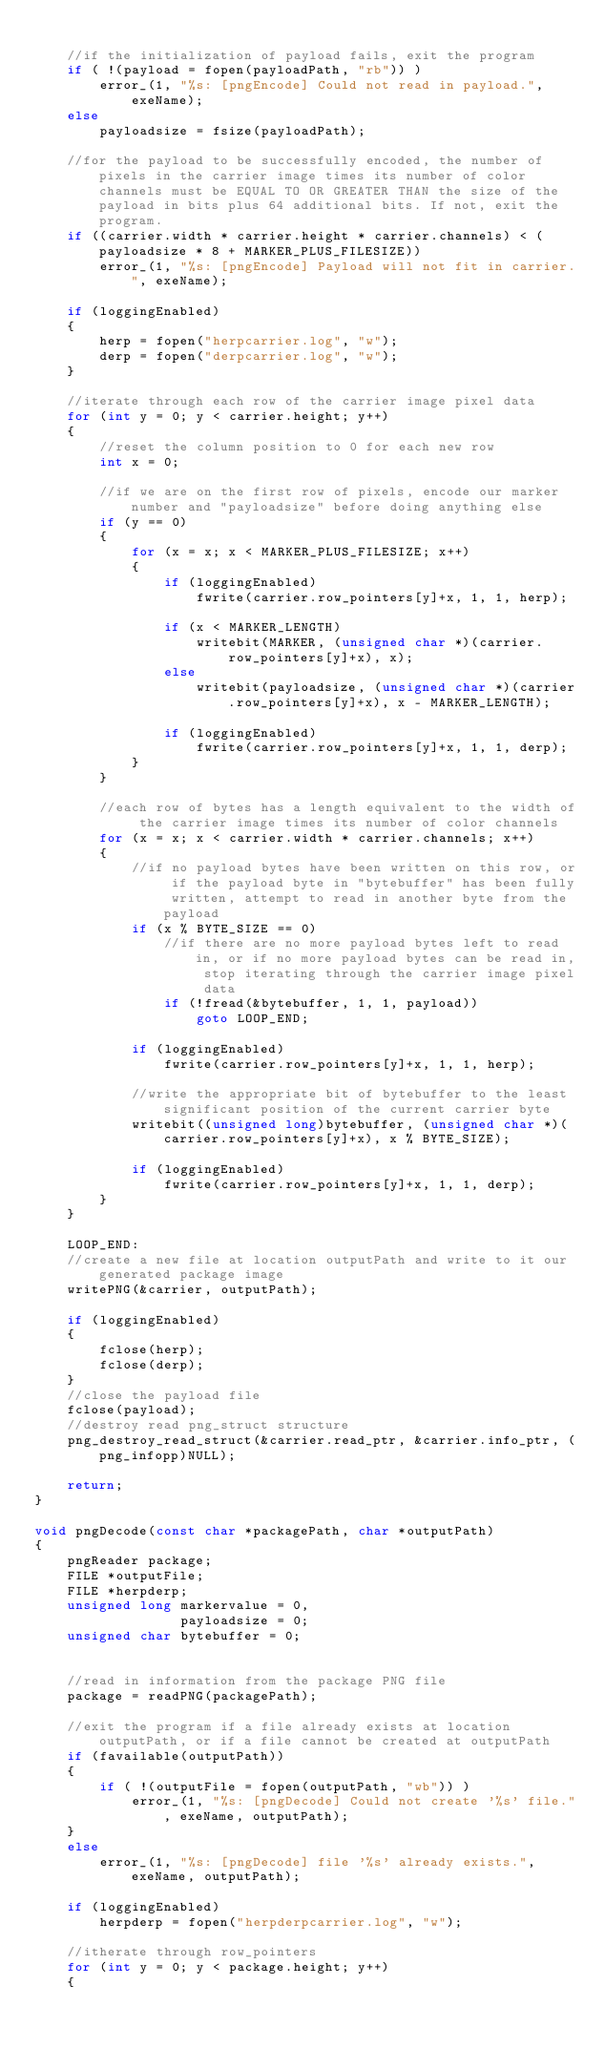Convert code to text. <code><loc_0><loc_0><loc_500><loc_500><_C_>
    //if the initialization of payload fails, exit the program
    if ( !(payload = fopen(payloadPath, "rb")) )
        error_(1, "%s: [pngEncode] Could not read in payload.", exeName);
    else
        payloadsize = fsize(payloadPath);

    //for the payload to be successfully encoded, the number of pixels in the carrier image times its number of color channels must be EQUAL TO OR GREATER THAN the size of the payload in bits plus 64 additional bits. If not, exit the program.
    if ((carrier.width * carrier.height * carrier.channels) < (payloadsize * 8 + MARKER_PLUS_FILESIZE))
        error_(1, "%s: [pngEncode] Payload will not fit in carrier.", exeName);

    if (loggingEnabled)
    {
        herp = fopen("herpcarrier.log", "w");
        derp = fopen("derpcarrier.log", "w");
    }

    //iterate through each row of the carrier image pixel data
    for (int y = 0; y < carrier.height; y++)
    {
        //reset the column position to 0 for each new row
        int x = 0;

        //if we are on the first row of pixels, encode our marker number and "payloadsize" before doing anything else
        if (y == 0)
        {
            for (x = x; x < MARKER_PLUS_FILESIZE; x++)
            {
                if (loggingEnabled)
                    fwrite(carrier.row_pointers[y]+x, 1, 1, herp);

                if (x < MARKER_LENGTH)
                    writebit(MARKER, (unsigned char *)(carrier.row_pointers[y]+x), x);
                else
                    writebit(payloadsize, (unsigned char *)(carrier.row_pointers[y]+x), x - MARKER_LENGTH);

                if (loggingEnabled)
                    fwrite(carrier.row_pointers[y]+x, 1, 1, derp);
            }
        }

        //each row of bytes has a length equivalent to the width of the carrier image times its number of color channels
        for (x = x; x < carrier.width * carrier.channels; x++)
        {
            //if no payload bytes have been written on this row, or if the payload byte in "bytebuffer" has been fully written, attempt to read in another byte from the payload
            if (x % BYTE_SIZE == 0)
                //if there are no more payload bytes left to read in, or if no more payload bytes can be read in, stop iterating through the carrier image pixel data
                if (!fread(&bytebuffer, 1, 1, payload))
                    goto LOOP_END;

            if (loggingEnabled)
                fwrite(carrier.row_pointers[y]+x, 1, 1, herp);

            //write the appropriate bit of bytebuffer to the least significant position of the current carrier byte
            writebit((unsigned long)bytebuffer, (unsigned char *)(carrier.row_pointers[y]+x), x % BYTE_SIZE);

            if (loggingEnabled)
                fwrite(carrier.row_pointers[y]+x, 1, 1, derp);
        }
    }

    LOOP_END:
    //create a new file at location outputPath and write to it our generated package image
    writePNG(&carrier, outputPath);

    if (loggingEnabled)
    {
        fclose(herp);
        fclose(derp);
    }
    //close the payload file
    fclose(payload);
    //destroy read png_struct structure
    png_destroy_read_struct(&carrier.read_ptr, &carrier.info_ptr, (png_infopp)NULL);

    return;
}

void pngDecode(const char *packagePath, char *outputPath)
{
    pngReader package;
    FILE *outputFile;
    FILE *herpderp;
    unsigned long markervalue = 0,
                  payloadsize = 0;
    unsigned char bytebuffer = 0;


    //read in information from the package PNG file
    package = readPNG(packagePath);

    //exit the program if a file already exists at location outputPath, or if a file cannot be created at outputPath
    if (favailable(outputPath))
    {
        if ( !(outputFile = fopen(outputPath, "wb")) )
            error_(1, "%s: [pngDecode] Could not create '%s' file.", exeName, outputPath);
    }
    else
        error_(1, "%s: [pngDecode] file '%s' already exists.", exeName, outputPath);

    if (loggingEnabled)
        herpderp = fopen("herpderpcarrier.log", "w");

    //itherate through row_pointers
    for (int y = 0; y < package.height; y++)
    {</code> 